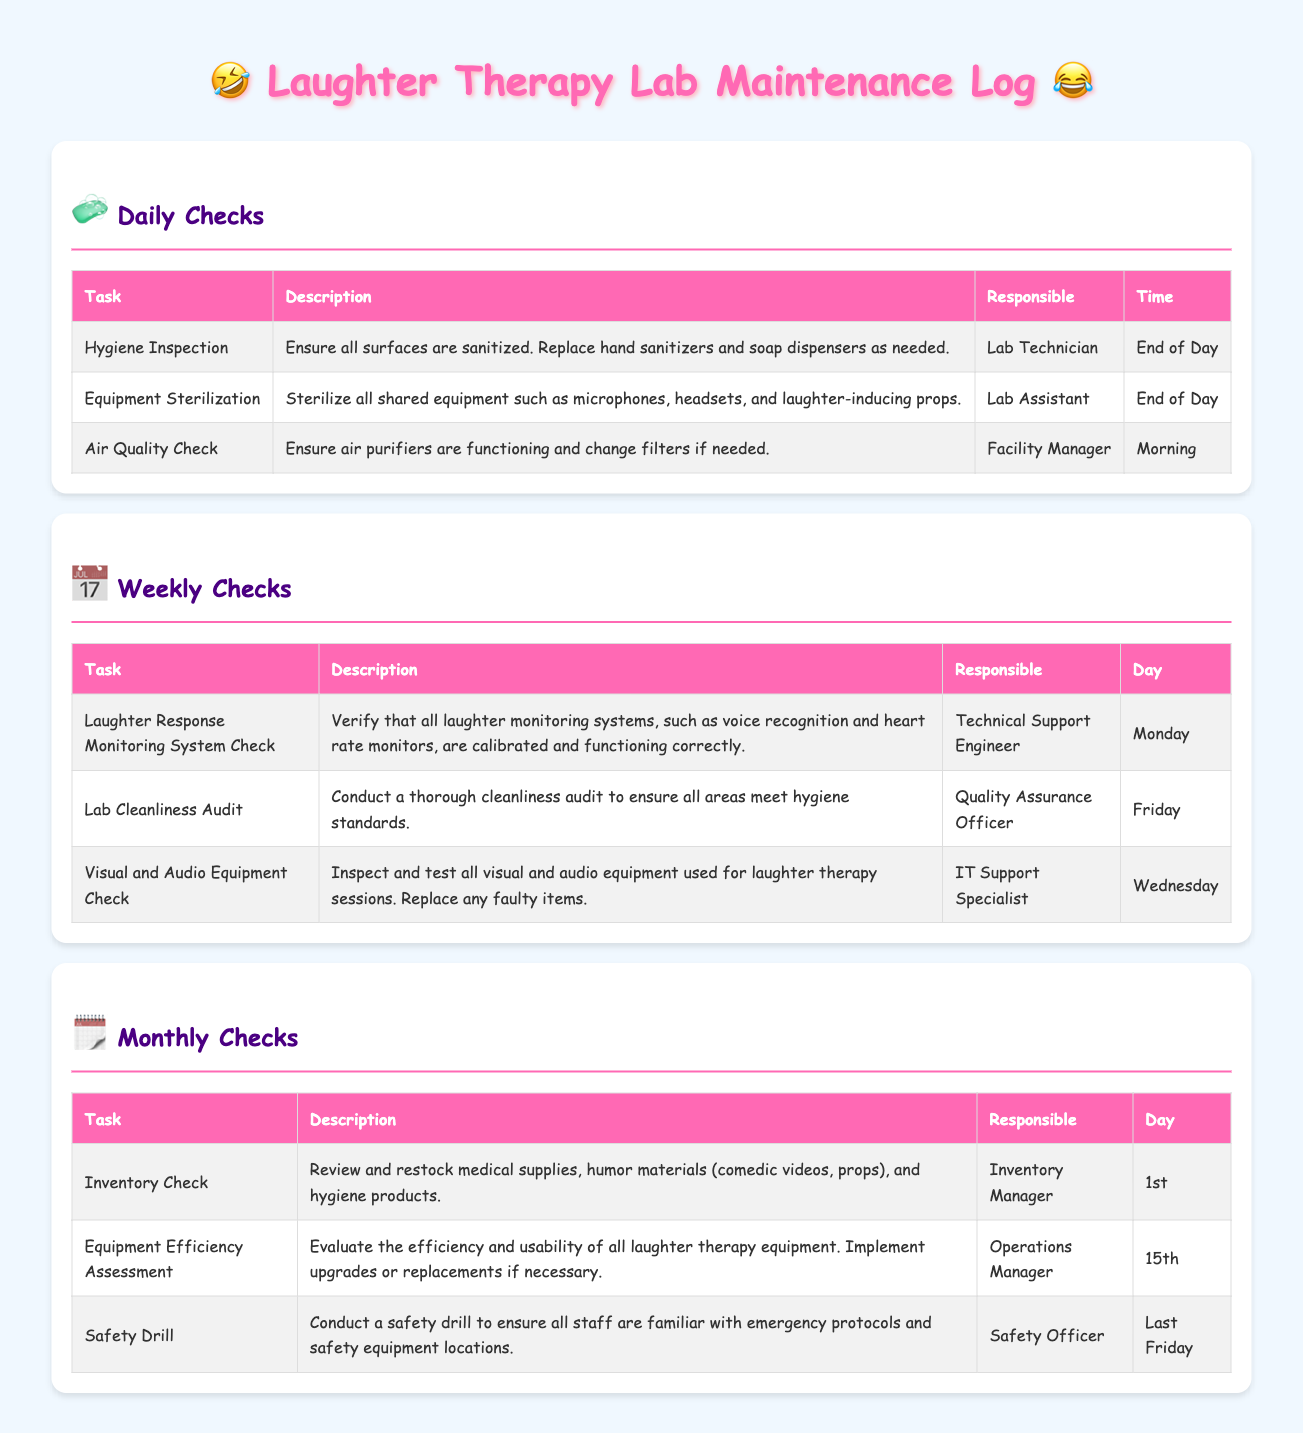what is the responsibility of the Lab Technician? The Lab Technician is responsible for ensuring all surfaces are sanitized and replacing hand sanitizers and soap dispensers as needed.
Answer: Hygiene Inspection what day is the Lab Cleanliness Audit conducted? The Lab Cleanliness Audit is conducted on Friday as listed in the weekly checks section.
Answer: Friday who conducts the Safety Drill? The Safety Officer is responsible for conducting the safety drill according to the monthly checks.
Answer: Safety Officer what is checked during the Equipment Efficiency Assessment? The Equipment Efficiency Assessment evaluates the efficiency and usability of all laughter therapy equipment and implements upgrades or replacements if necessary.
Answer: Equipment efficiency and usability how often are air quality checks performed? Air quality checks are conducted daily, specifically in the morning as per the daily checks section.
Answer: Daily 